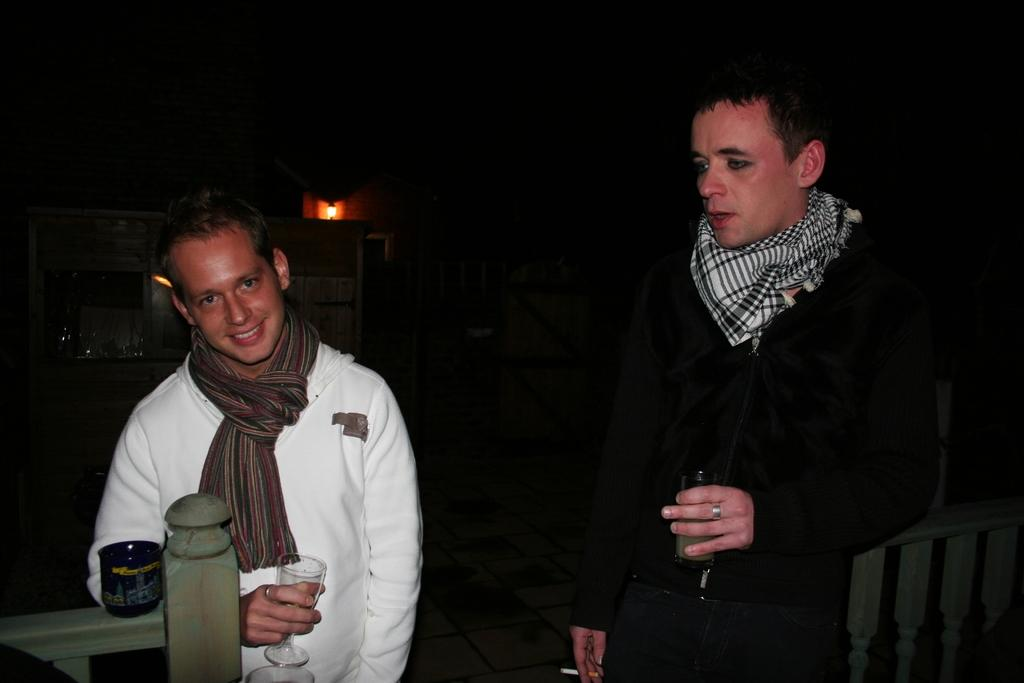How many people are in the foreground of the picture? There are two persons in the foreground of the picture. What is located in the foreground of the picture alongside the people? There is a railing in the foreground of the picture. What can be seen in the background of the picture? There is a building and light visible in the background of the picture. How would you describe the lighting conditions at the top of the image? The top of the image is dark. What type of wood is being used to create divisions in the image? There is no wood or divisions present in the image. Can you see any frogs in the image? There are no frogs visible in the image. 